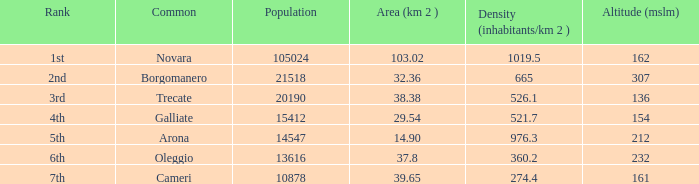I'm looking to parse the entire table for insights. Could you assist me with that? {'header': ['Rank', 'Common', 'Population', 'Area (km 2 )', 'Density (inhabitants/km 2 )', 'Altitude (mslm)'], 'rows': [['1st', 'Novara', '105024', '103.02', '1019.5', '162'], ['2nd', 'Borgomanero', '21518', '32.36', '665', '307'], ['3rd', 'Trecate', '20190', '38.38', '526.1', '136'], ['4th', 'Galliate', '15412', '29.54', '521.7', '154'], ['5th', 'Arona', '14547', '14.90', '976.3', '212'], ['6th', 'Oleggio', '13616', '37.8', '360.2', '232'], ['7th', 'Cameri', '10878', '39.65', '274.4', '161']]} In all the commons, what is the minimum height above mean sea level (mslm)? 136.0. 